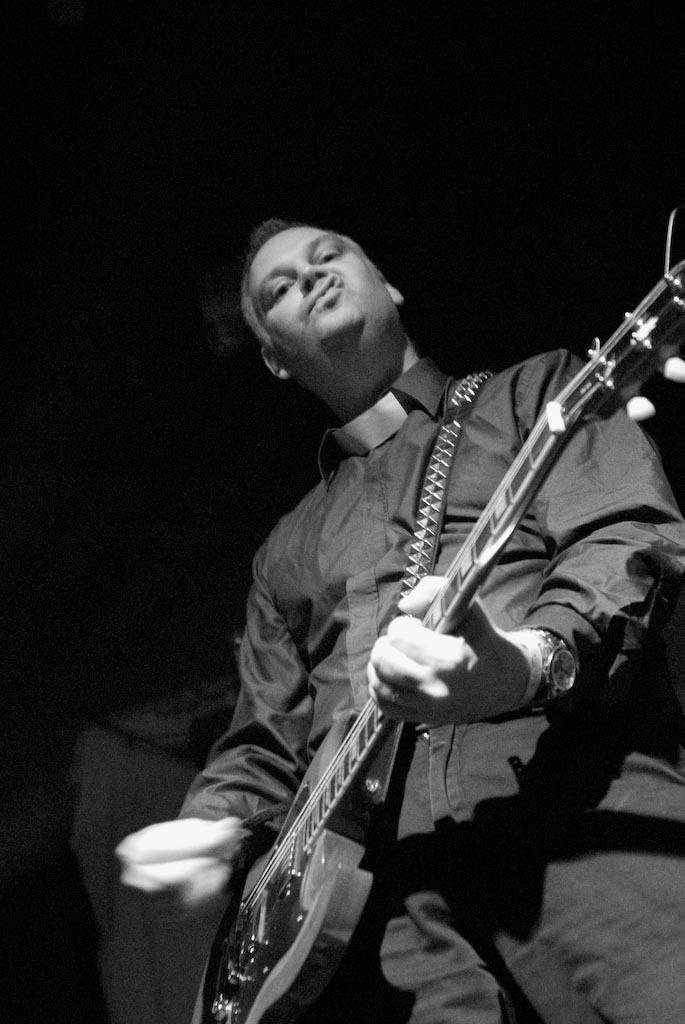What is the main subject of the image? There is a person in the image. What is the person doing in the image? The person is standing and playing a guitar. What accessory is the person wearing in the image? The person is wearing a watch. What is the color scheme of the image? The image is black and white. How many goats are visible in the image? There are no goats present in the image. What type of can is the person holding in the image? There is no can present in the image; the person is playing a guitar. 